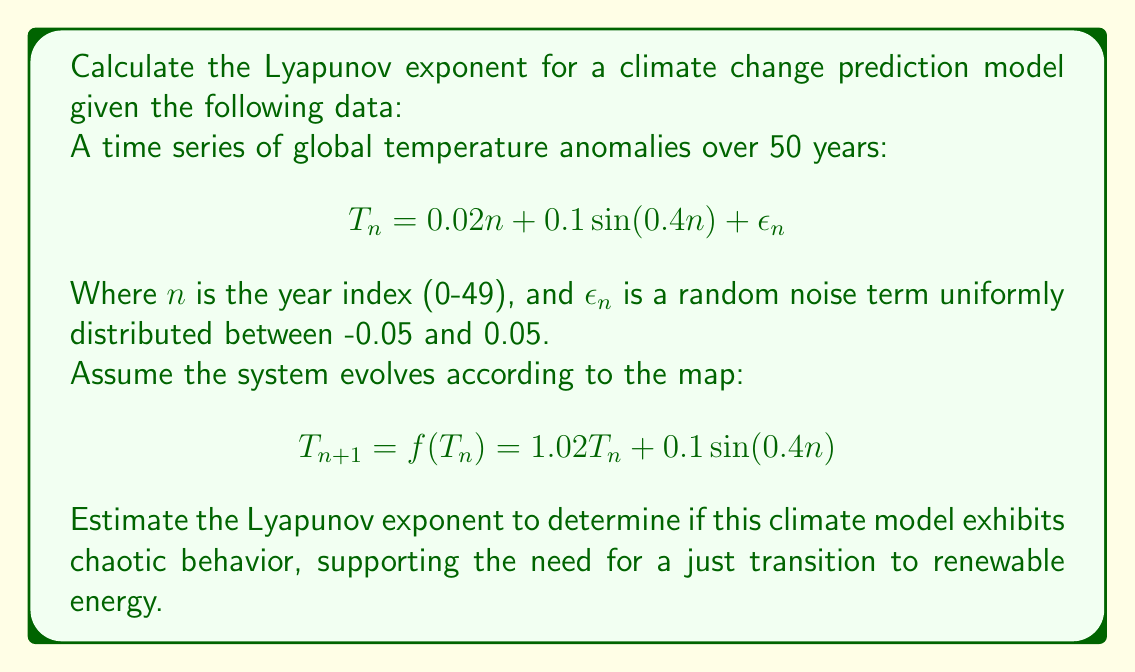Show me your answer to this math problem. To calculate the Lyapunov exponent for this climate change prediction model, we'll follow these steps:

1) The Lyapunov exponent $\lambda$ is defined as:

   $$\lambda = \lim_{N \to \infty} \frac{1}{N} \sum_{n=0}^{N-1} \ln|f'(T_n)|$$

2) For our map $f(T_n) = 1.02T_n + 0.1\sin(0.4n)$, we need to find $f'(T_n)$:

   $$f'(T_n) = 1.02$$

3) Substituting this into the Lyapunov exponent formula:

   $$\lambda = \lim_{N \to \infty} \frac{1}{N} \sum_{n=0}^{N-1} \ln|1.02|$$

4) Since $f'(T_n)$ is constant, we can simplify:

   $$\lambda = \ln|1.02|$$

5) Calculate the natural logarithm:

   $$\lambda \approx 0.0198$$

6) Interpret the result:
   - If $\lambda > 0$, the system is chaotic
   - If $\lambda < 0$, the system is stable
   - If $\lambda = 0$, the system is conservative

In this case, $\lambda > 0$, indicating that the climate model exhibits chaotic behavior. This supports the advocate's position on the need for a just transition to renewable energy, as it demonstrates the unpredictability and potential instability of the climate system under current conditions.
Answer: $\lambda \approx 0.0198$ (chaotic behavior) 